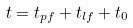<formula> <loc_0><loc_0><loc_500><loc_500>t = t _ { p f } + t _ { l f } + t _ { 0 }</formula> 